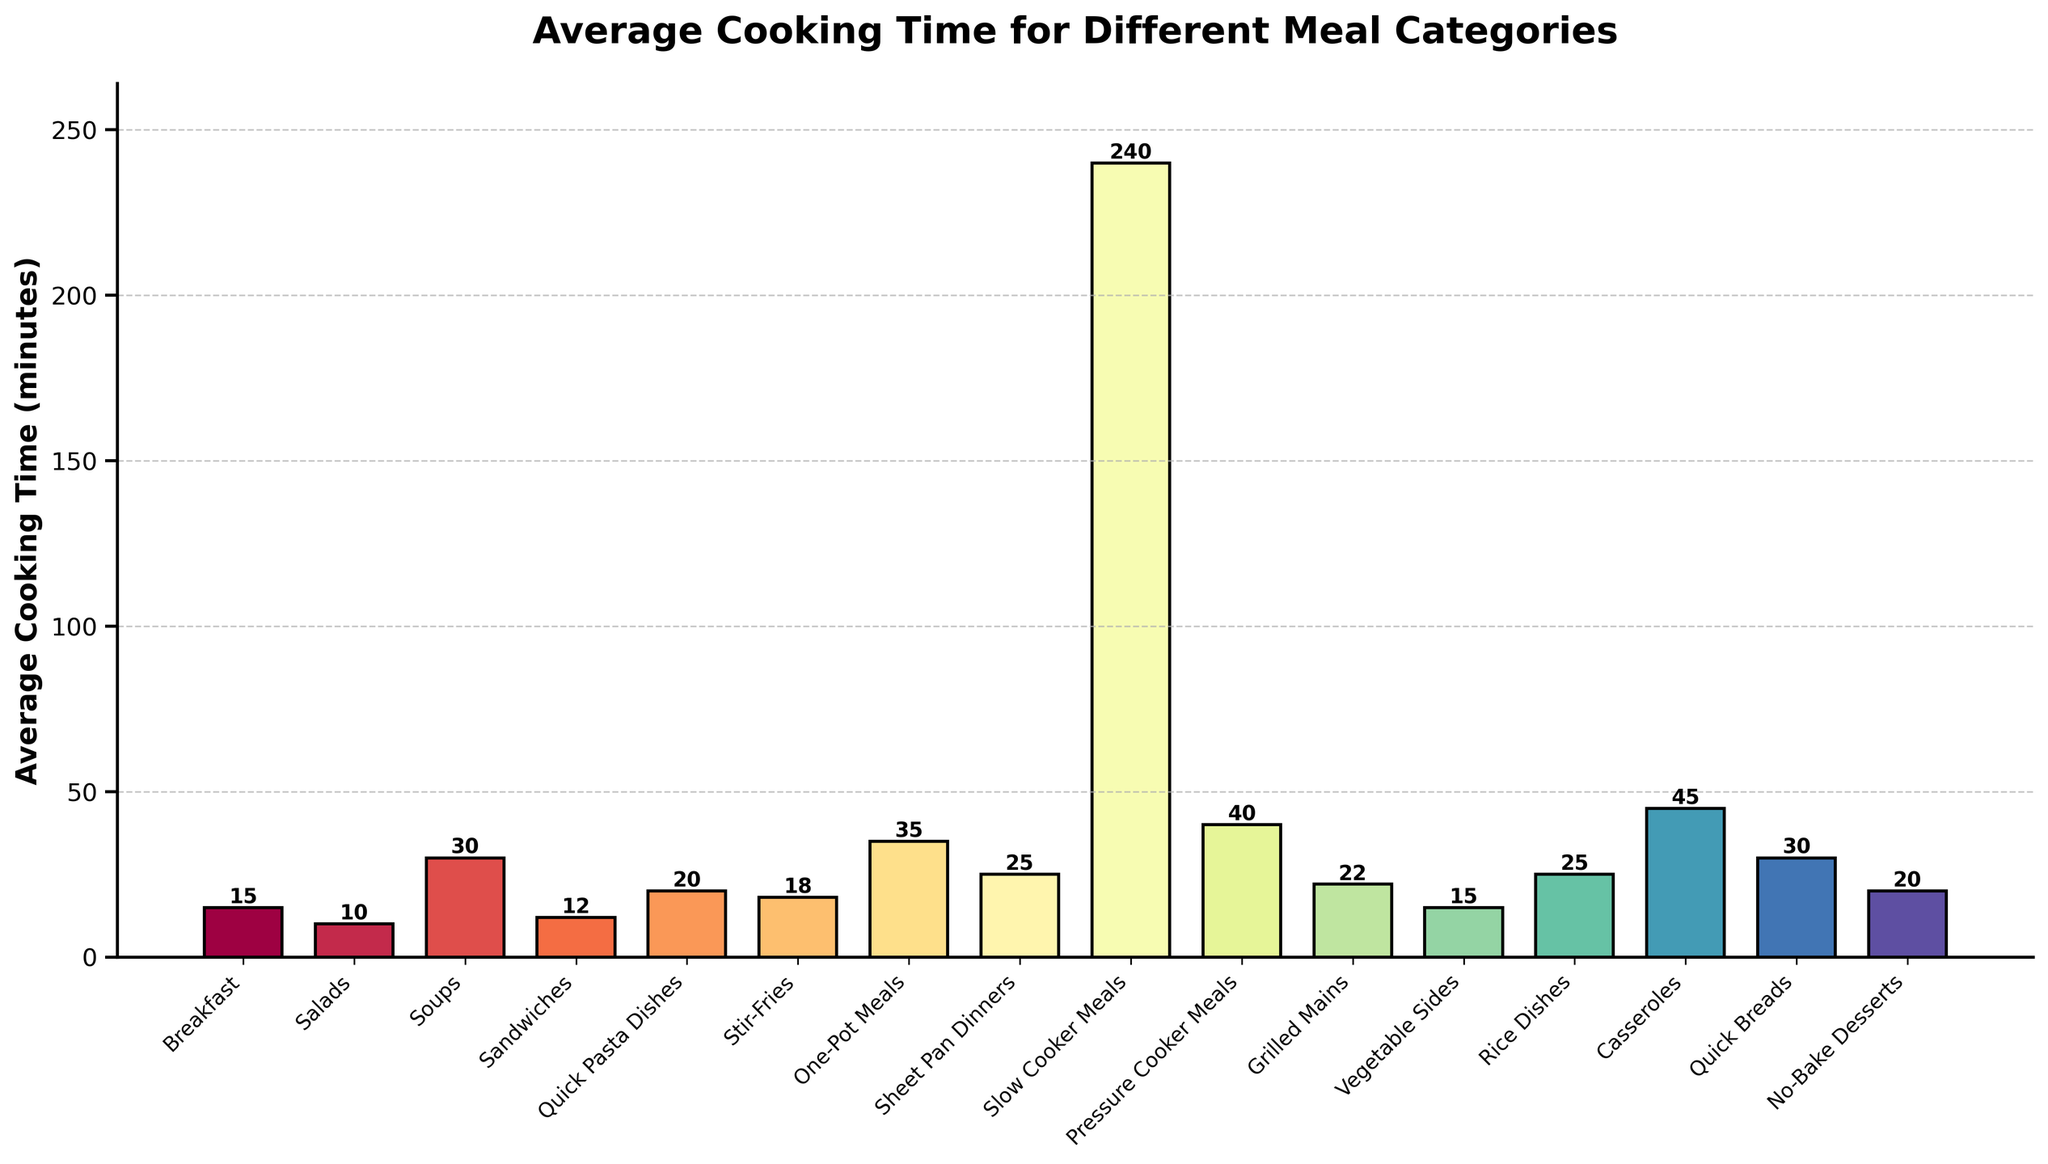Which meal category has the highest average cooking time? The bar representing "Slow Cooker Meals" is the tallest among all categories, indicating the highest average cooking time.
Answer: Slow Cooker Meals Which meal category has the lowest average cooking time? The bar representing "Salads" is the shortest among all categories, indicating the lowest average cooking time.
Answer: Salads How much time difference is there between Slow Cooker Meals and Sheet Pan Dinners? Slow Cooker Meals have an average cooking time of 240 minutes, and Sheet Pan Dinners have an average cooking time of 25 minutes. The difference is 240 - 25.
Answer: 215 minutes Are Soups quicker to cook than Casseroles? The average cooking time for Soups is 30 minutes, whereas for Casseroles, it is 45 minutes. Hence, Soups are quicker to cook.
Answer: Yes Which two categories have the same average cooking time? The bars for Breakfast and Vegetable Sides both have the same height, indicating the same average cooking time.
Answer: Breakfast and Vegetable Sides What is the combined average cooking time for One-Pot Meals and Rice Dishes? The average cooking time for One-Pot Meals is 35 minutes, and for Rice Dishes, it is 25 minutes. The combined total is 35 + 25.
Answer: 60 minutes Is the average cooking time for Pressure Cooker Meals more than twice that of Breakfast? The average cooking time for Pressure Cooker Meals is 40 minutes, and for Breakfast, it is 15 minutes. 15 * 2 = 30, which is less than 40.
Answer: Yes Which category is quicker to cook: Quick Pasta Dishes or Grilled Mains? The average cooking time for Quick Pasta Dishes is 20 minutes, whereas for Grilled Mains, it is 22 minutes. So Quick Pasta Dishes are quicker.
Answer: Quick Pasta Dishes How much longer does it take to cook Casseroles compared to Soups? The average cooking time for Casseroles is 45 minutes, and for Soups, it is 30 minutes. The difference is 45 - 30.
Answer: 15 minutes What is the average cooking time for the three quickest meal categories combined? The three quickest categories are Salads (10 minutes), Sandwiches (12 minutes), and Breakfast or Vegetable Sides (both 15 minutes). The sum is 10 + 12 + 15.
Answer: 37 minutes 